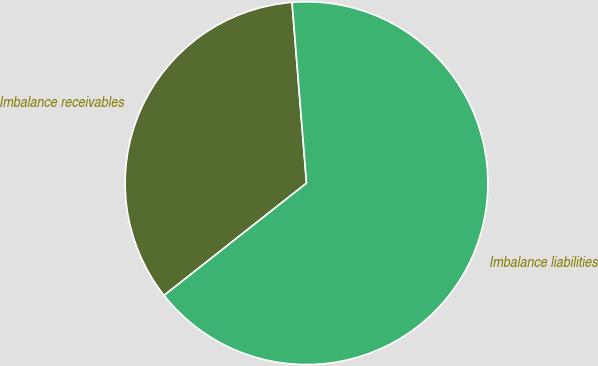Convert chart. <chart><loc_0><loc_0><loc_500><loc_500><pie_chart><fcel>Imbalance receivables<fcel>Imbalance liabilities<nl><fcel>34.35%<fcel>65.65%<nl></chart> 